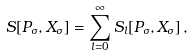<formula> <loc_0><loc_0><loc_500><loc_500>S [ P _ { \sigma } , X _ { \sigma } ] = \sum _ { l = 0 } ^ { \infty } S _ { l } [ P _ { \sigma } , X _ { \sigma } ] \, ,</formula> 